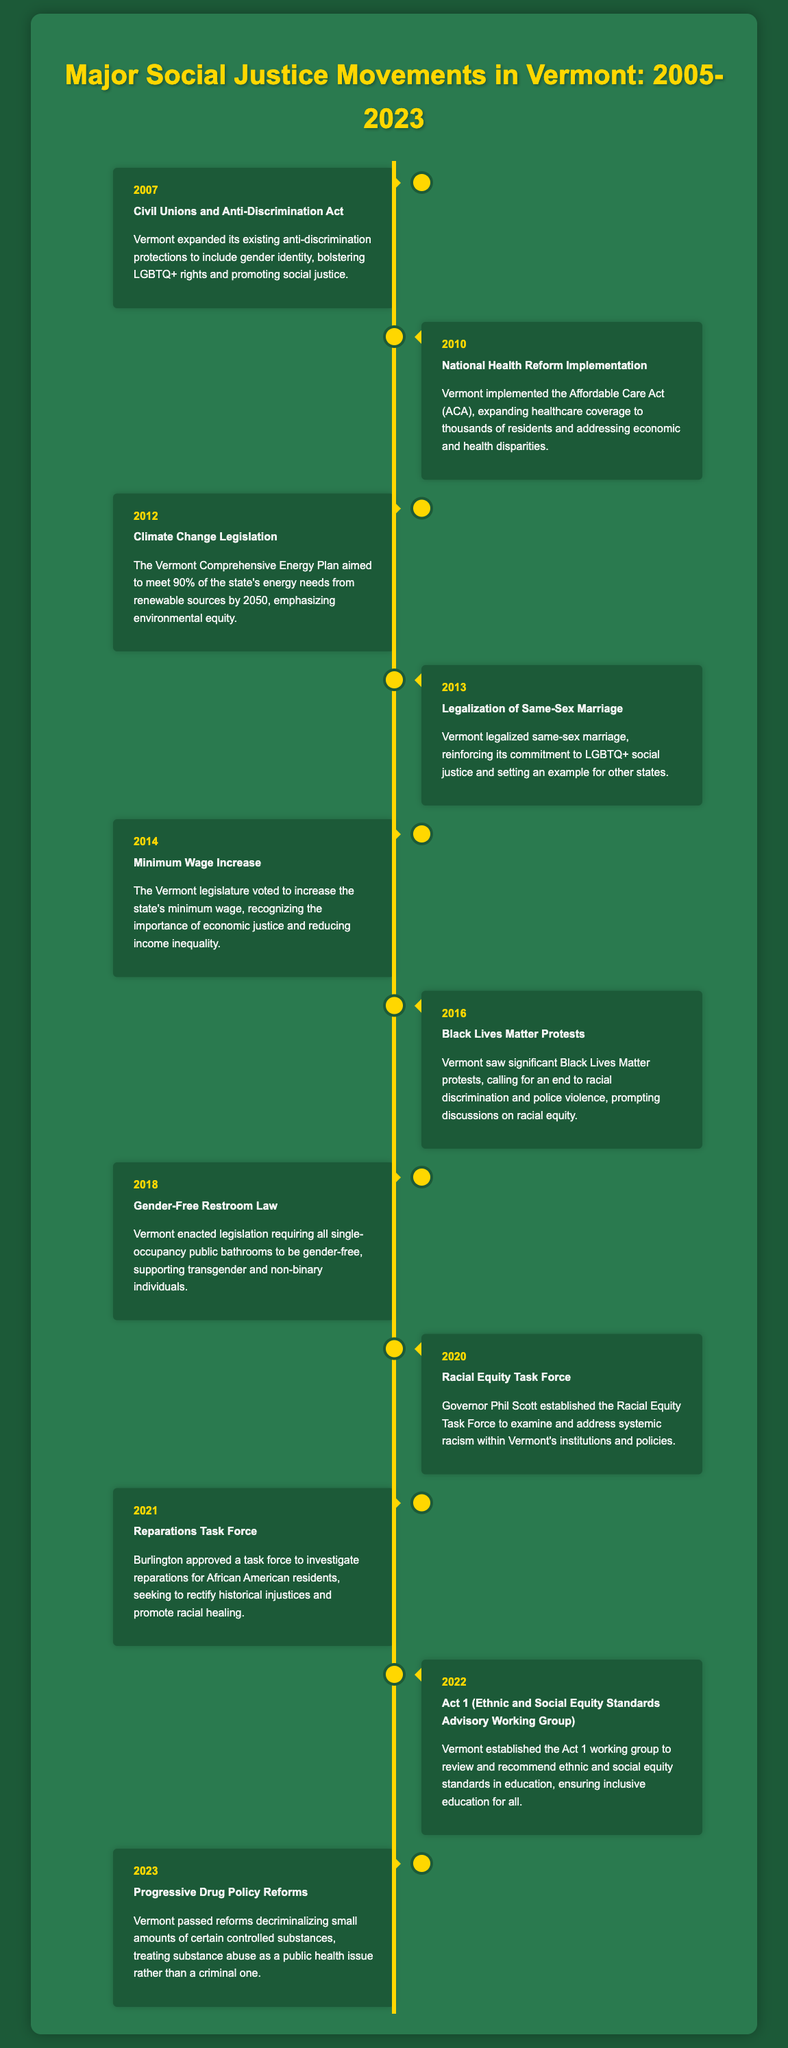What event expanded anti-discrimination protections in 2007? The event in 2007 was the expansion of existing anti-discrimination protections to include gender identity, bolstering LGBTQ+ rights.
Answer: Civil Unions and Anti-Discrimination Act What year was same-sex marriage legalized in Vermont? The legalization of same-sex marriage occurred in 2013.
Answer: 2013 Which movement called for an end to racial discrimination in 2016? The significant movement in 2016 that called for an end to racial discrimination was the Black Lives Matter protests.
Answer: Black Lives Matter Protests What legislative action did Vermont take regarding the minimum wage in 2014? Vermont's legislature voted to increase the state's minimum wage in 2014, recognizing the importance of economic justice.
Answer: Minimum Wage Increase What task force was established in 2020 to address systemic racism? The Racial Equity Task Force was established by Governor Phil Scott in 2020 to examine and address systemic racism.
Answer: Racial Equity Task Force In what year did Vermont pass reforms decriminalizing certain controlled substances? The reforms decriminalizing small amounts of certain controlled substances were passed in 2023.
Answer: 2023 Which act in 2022 focused on ethnic and social equity standards in education? The legislation established in 2022 for ethnic and social equity standards in education was Act 1.
Answer: Act 1 What environmental goal was set by the Vermont Comprehensive Energy Plan in 2012? The goal set was to meet 90% of the state's energy needs from renewable sources by 2050.
Answer: 90% renewable energy by 2050 What does the Reparations Task Force in Burlington aim to investigate? The task force seeks to investigate reparations for African American residents to rectify historical injustices.
Answer: Investigate reparations 